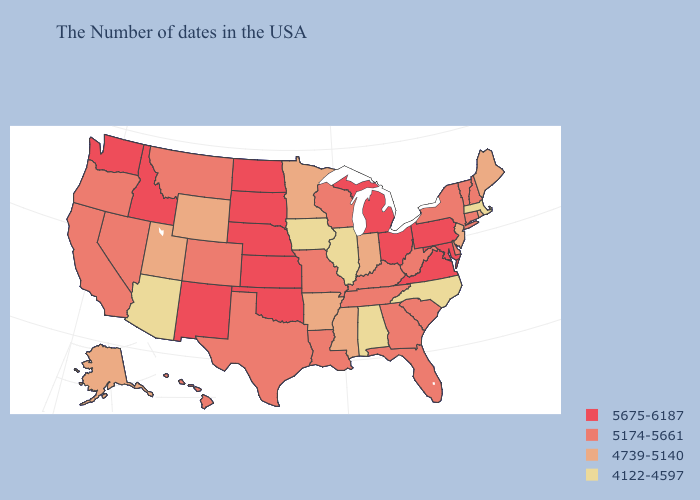What is the lowest value in the USA?
Give a very brief answer. 4122-4597. Is the legend a continuous bar?
Be succinct. No. Name the states that have a value in the range 5174-5661?
Give a very brief answer. New Hampshire, Vermont, Connecticut, New York, Delaware, South Carolina, West Virginia, Florida, Georgia, Kentucky, Tennessee, Wisconsin, Louisiana, Missouri, Texas, Colorado, Montana, Nevada, California, Oregon, Hawaii. Which states hav the highest value in the MidWest?
Write a very short answer. Ohio, Michigan, Kansas, Nebraska, South Dakota, North Dakota. What is the lowest value in states that border North Carolina?
Write a very short answer. 5174-5661. Does the first symbol in the legend represent the smallest category?
Answer briefly. No. What is the lowest value in the USA?
Write a very short answer. 4122-4597. Among the states that border Washington , which have the lowest value?
Quick response, please. Oregon. Name the states that have a value in the range 4739-5140?
Short answer required. Maine, Rhode Island, New Jersey, Indiana, Mississippi, Arkansas, Minnesota, Wyoming, Utah, Alaska. What is the lowest value in the West?
Answer briefly. 4122-4597. Does Washington have the highest value in the West?
Short answer required. Yes. What is the value of Virginia?
Quick response, please. 5675-6187. Among the states that border Utah , does New Mexico have the highest value?
Short answer required. Yes. Among the states that border Alabama , which have the lowest value?
Answer briefly. Mississippi. Which states have the lowest value in the South?
Quick response, please. North Carolina, Alabama. 